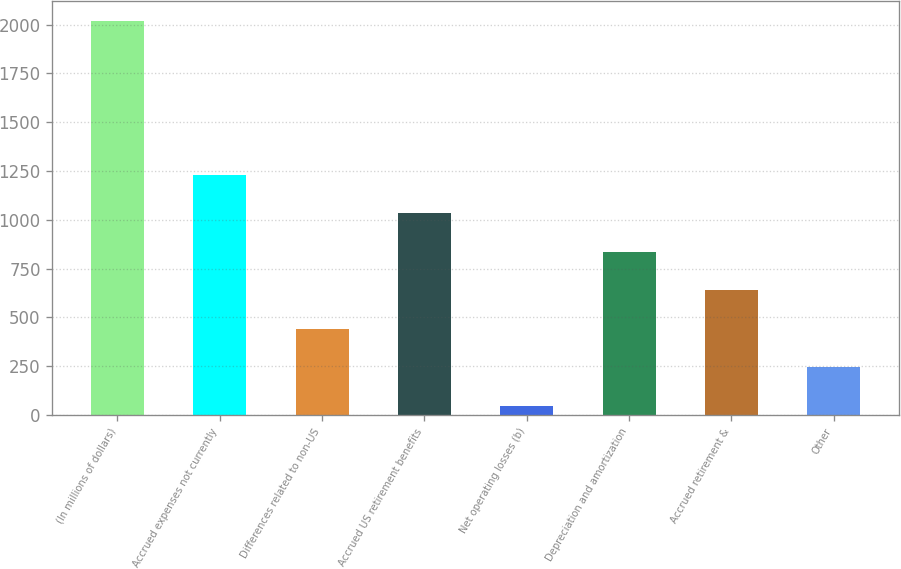<chart> <loc_0><loc_0><loc_500><loc_500><bar_chart><fcel>(In millions of dollars)<fcel>Accrued expenses not currently<fcel>Differences related to non-US<fcel>Accrued US retirement benefits<fcel>Net operating losses (b)<fcel>Depreciation and amortization<fcel>Accrued retirement &<fcel>Other<nl><fcel>2018<fcel>1230<fcel>442<fcel>1033<fcel>48<fcel>836<fcel>639<fcel>245<nl></chart> 